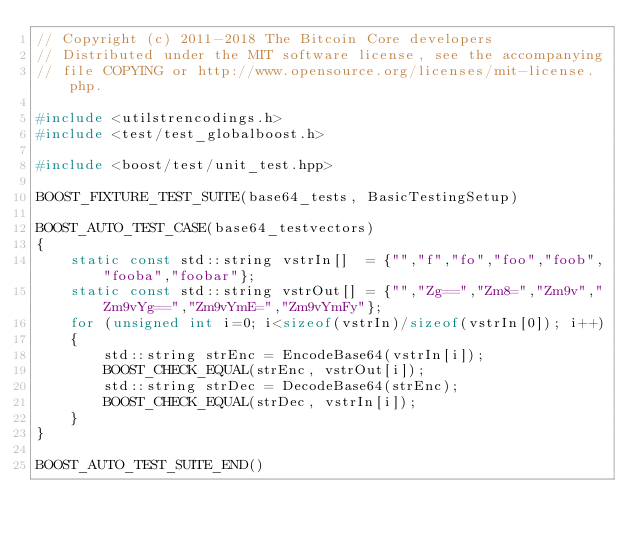Convert code to text. <code><loc_0><loc_0><loc_500><loc_500><_C++_>// Copyright (c) 2011-2018 The Bitcoin Core developers
// Distributed under the MIT software license, see the accompanying
// file COPYING or http://www.opensource.org/licenses/mit-license.php.

#include <utilstrencodings.h>
#include <test/test_globalboost.h>

#include <boost/test/unit_test.hpp>

BOOST_FIXTURE_TEST_SUITE(base64_tests, BasicTestingSetup)

BOOST_AUTO_TEST_CASE(base64_testvectors)
{
    static const std::string vstrIn[]  = {"","f","fo","foo","foob","fooba","foobar"};
    static const std::string vstrOut[] = {"","Zg==","Zm8=","Zm9v","Zm9vYg==","Zm9vYmE=","Zm9vYmFy"};
    for (unsigned int i=0; i<sizeof(vstrIn)/sizeof(vstrIn[0]); i++)
    {
        std::string strEnc = EncodeBase64(vstrIn[i]);
        BOOST_CHECK_EQUAL(strEnc, vstrOut[i]);
        std::string strDec = DecodeBase64(strEnc);
        BOOST_CHECK_EQUAL(strDec, vstrIn[i]);
    }
}

BOOST_AUTO_TEST_SUITE_END()
</code> 